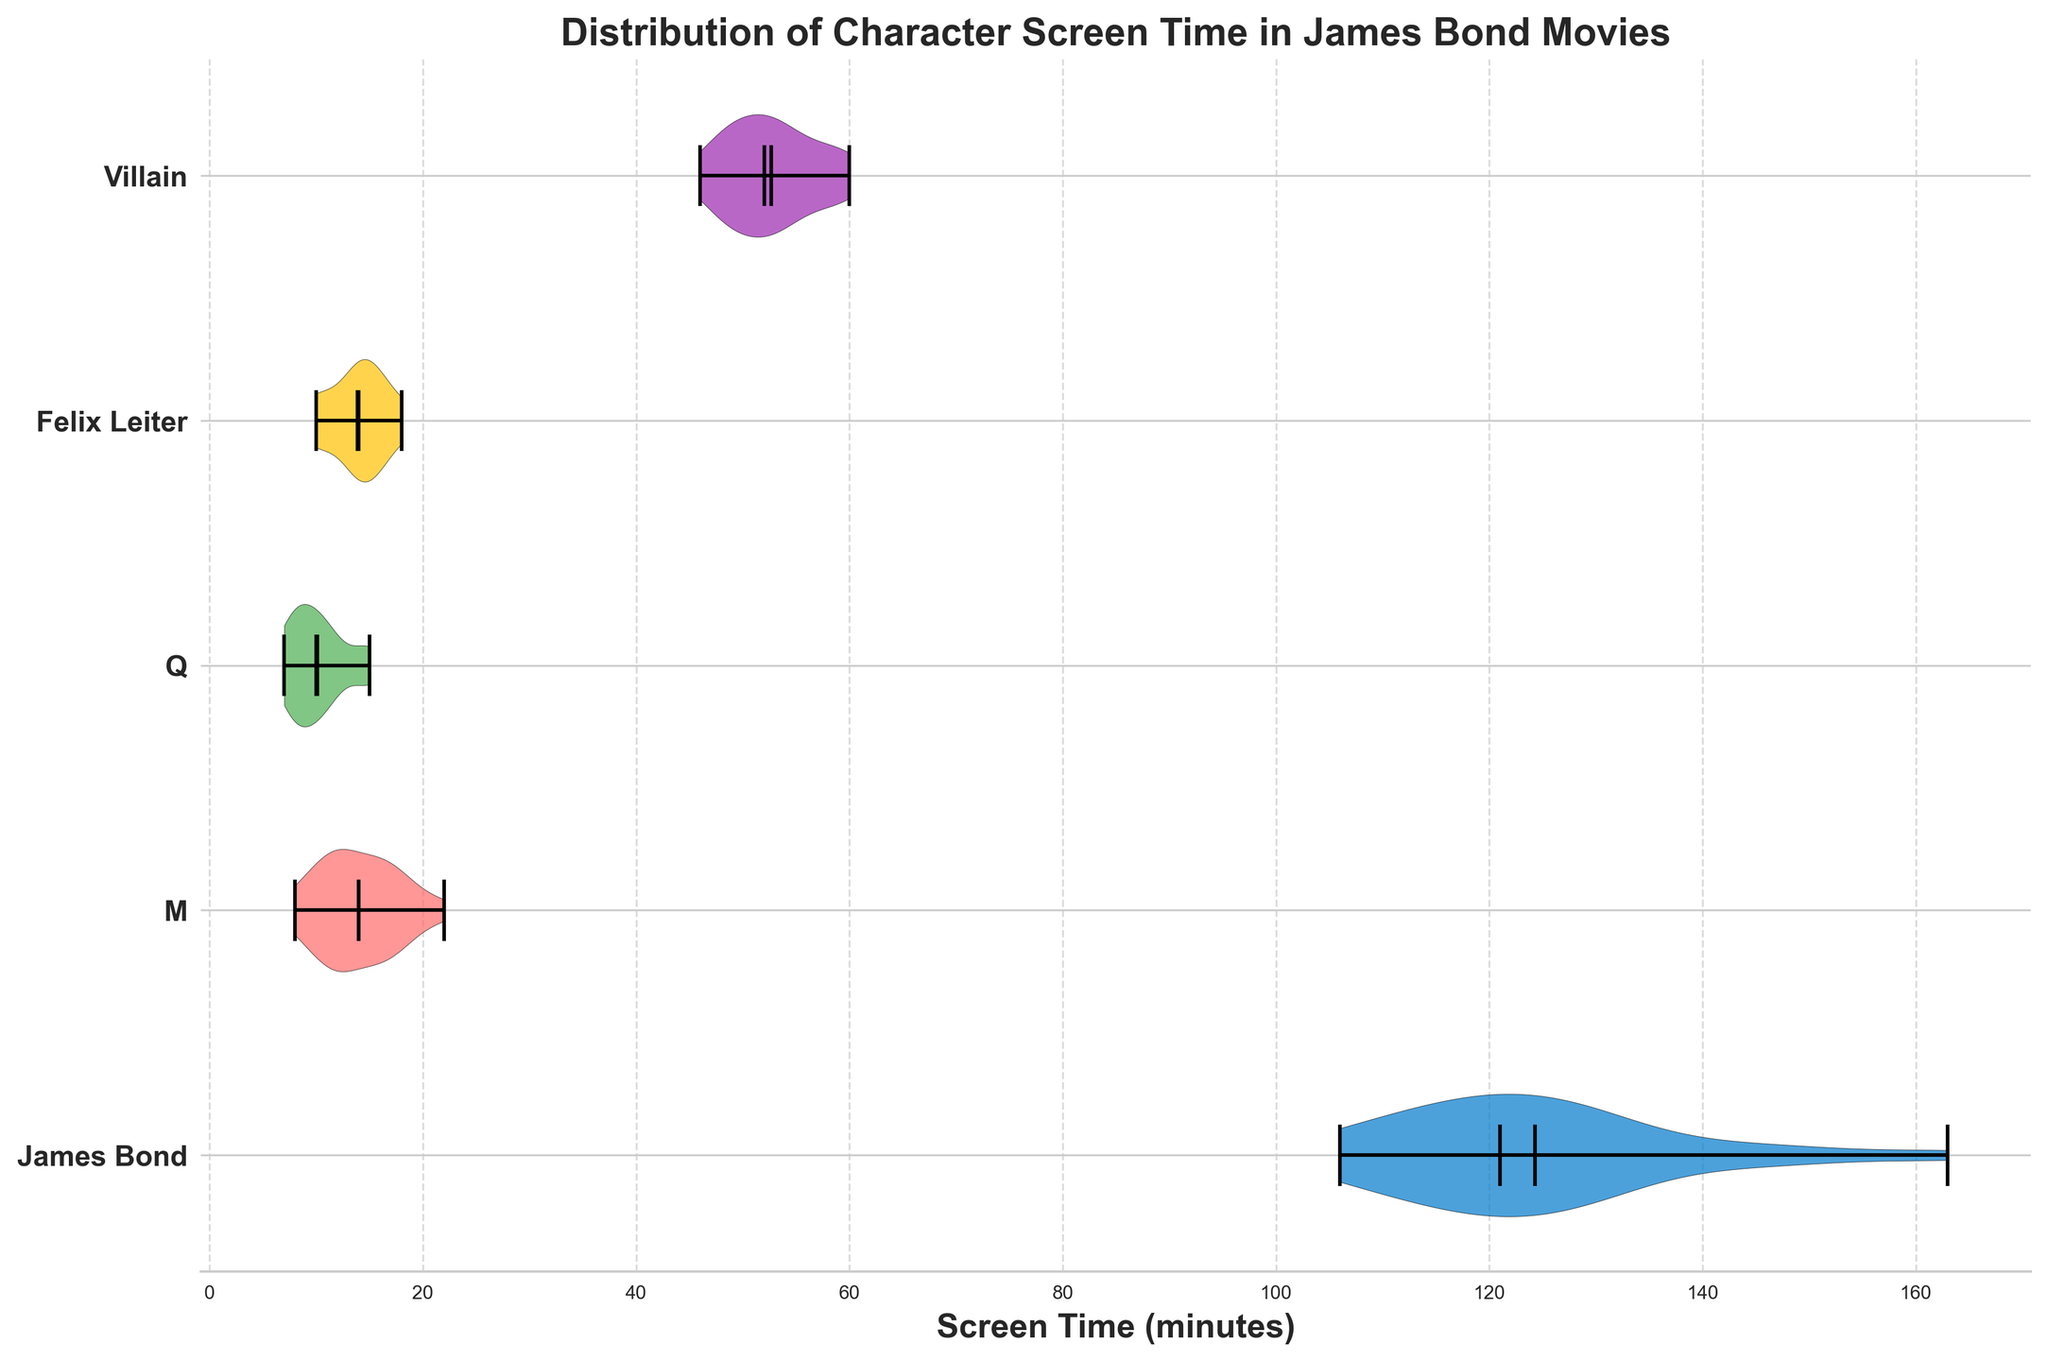What is the title of the figure? The title is typically displayed at the top of the plot. In this case, it is stated as "Distribution of Character Screen Time in James Bond Movies."
Answer: Distribution of Character Screen Time in James Bond Movies Which character has the highest median screen time? The median value is typically shown by a bold line crossing the violin plot. The character with the highest median screen time will have this bold line positioned furthest to the right.
Answer: James Bond How does the median screen time of the villains compare to the screen time of Felix Leiter? By comparing the bold median lines of the "Villain" and "Felix Leiter" violin plots, you can observe that the "Villain" character's median line is further to the right on the horizontal axis than that of Felix Leiter, indicating a higher median screen time.
Answer: Villain's median screen time is higher What is the maximum screen time for James Bond? The maximum screen time is indicated by the farthest right extent of the violin plot for James Bond.
Answer: 163 minutes Which character has the widest range of screen time? The widest range of screen time can be identified by looking at the total length of the violin plot, from the minimum to the maximum points.
Answer: James Bond Which character has the narrowest range of screen time? To find the character with the narrowest range, look for the shortest violin plot horizontally, from the minimum to the maximum points.
Answer: M What is the mean screen time for the character M? The mean value is often shown as a dot in the violin plot. For M, identify this dot and note its position on the horizontal axis.
Answer: 14 minutes Compare the mean screen times of Q and Felix Leiter. Which one is higher? Mean values are depicted as dots in the violin plots. By identifying and comparing the dot positions for Q and Felix Leiter, we can see that Felix Leiter's dot is further to the right.
Answer: Felix Leiter What is the screen time distribution shape for James Bond? This refers to the overall shape of the James Bond violin plot. The distribution is dense in the middle and flares out at the ends, indicating variation in middle values with a few extremes on both sides.
Answer: Symmetrical with heavy concentration in the middle What period or spread can be observed for M's screen time? Examining the width and tapering of M's plot, we note that it's narrow and fairly consistent, indicating smaller variation and less spread in screen times.
Answer: Narrow, with less variation 